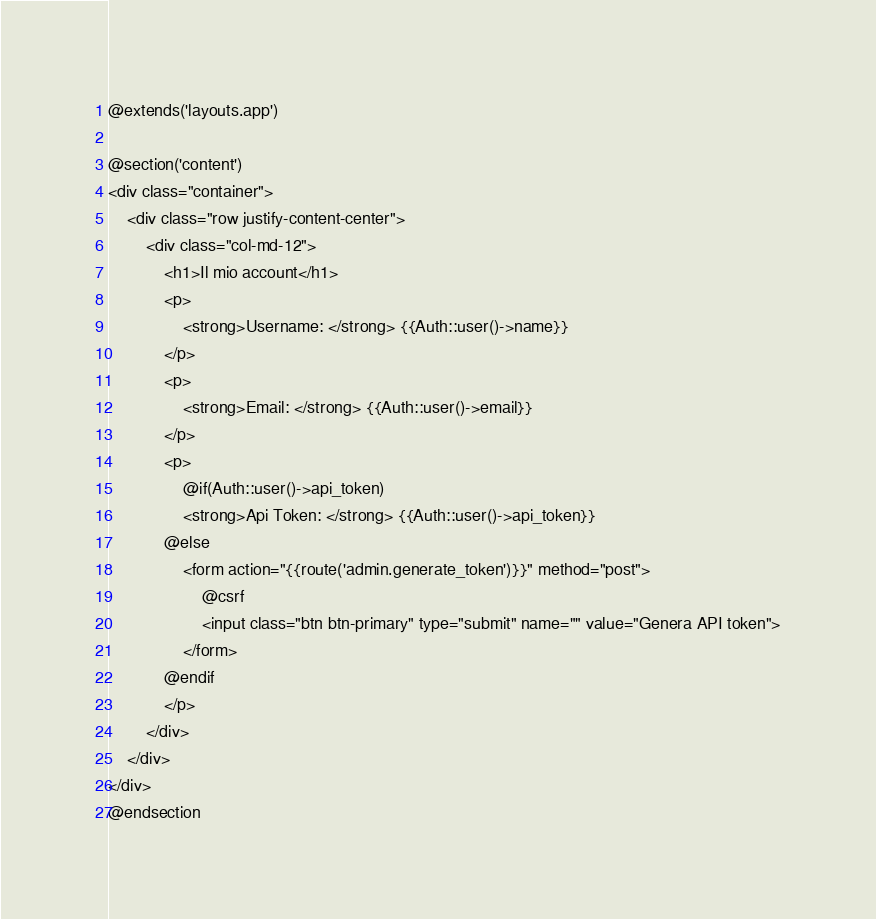<code> <loc_0><loc_0><loc_500><loc_500><_PHP_>@extends('layouts.app')

@section('content')
<div class="container">
    <div class="row justify-content-center">
        <div class="col-md-12">
            <h1>Il mio account</h1>
            <p>
                <strong>Username: </strong> {{Auth::user()->name}}
            </p>
            <p>
                <strong>Email: </strong> {{Auth::user()->email}}
            </p>
            <p>
                @if(Auth::user()->api_token)
                <strong>Api Token: </strong> {{Auth::user()->api_token}}
            @else
                <form action="{{route('admin.generate_token')}}" method="post">
                    @csrf
                    <input class="btn btn-primary" type="submit" name="" value="Genera API token">
                </form>
            @endif
            </p>
        </div>
    </div>
</div>
@endsection
</code> 